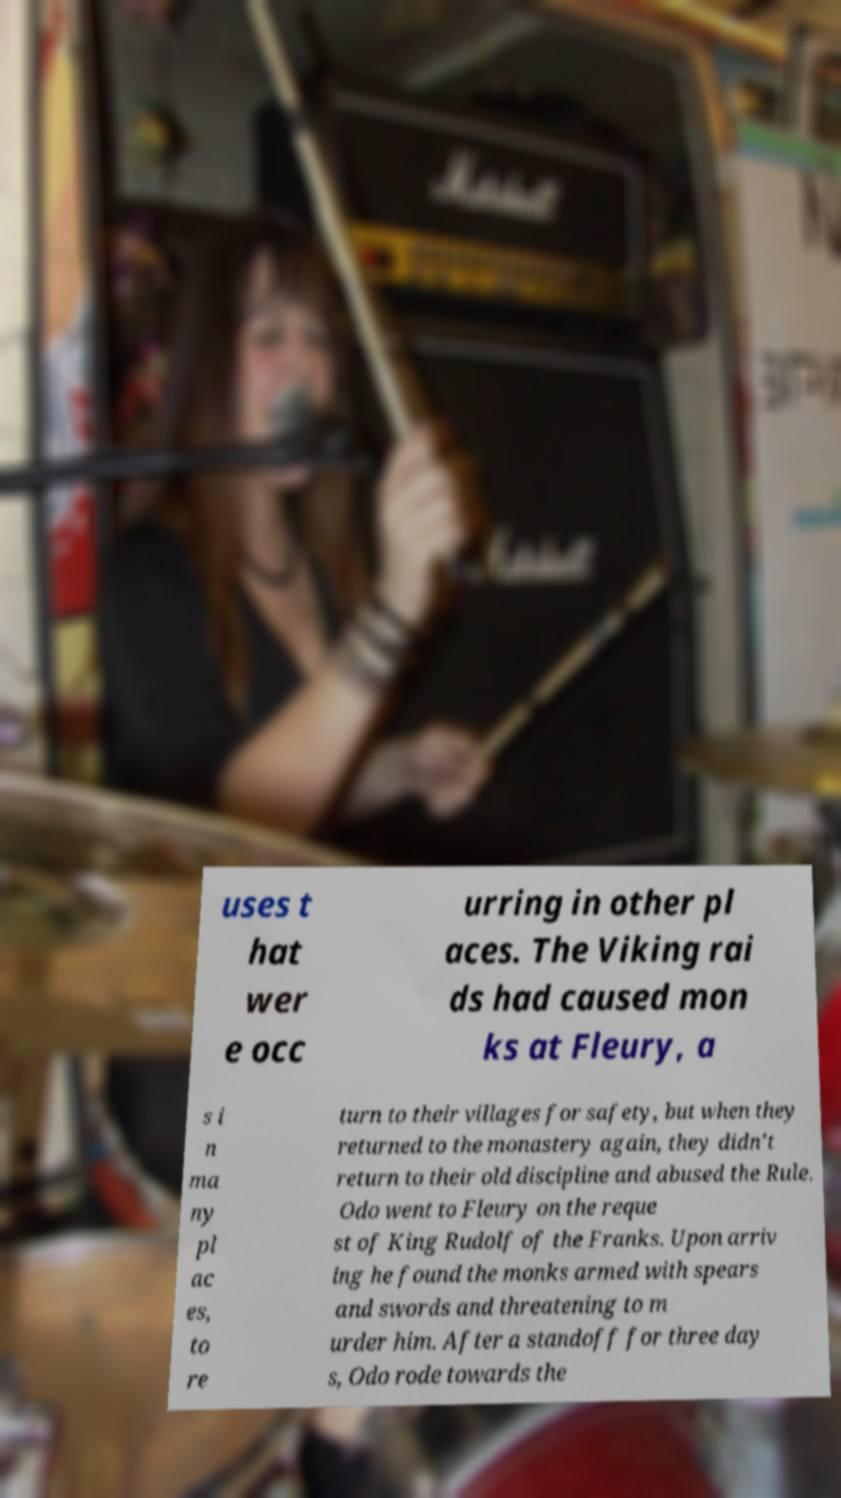For documentation purposes, I need the text within this image transcribed. Could you provide that? uses t hat wer e occ urring in other pl aces. The Viking rai ds had caused mon ks at Fleury, a s i n ma ny pl ac es, to re turn to their villages for safety, but when they returned to the monastery again, they didn't return to their old discipline and abused the Rule. Odo went to Fleury on the reque st of King Rudolf of the Franks. Upon arriv ing he found the monks armed with spears and swords and threatening to m urder him. After a standoff for three day s, Odo rode towards the 